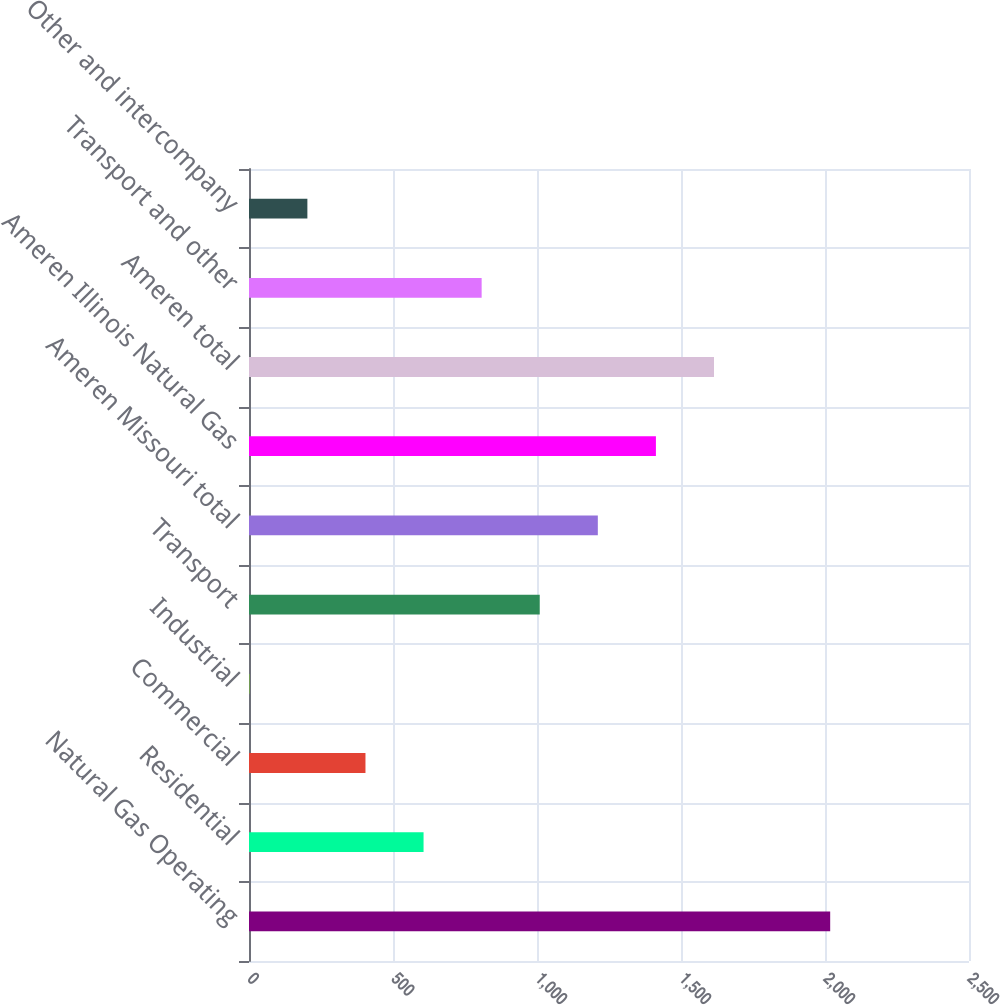Convert chart to OTSL. <chart><loc_0><loc_0><loc_500><loc_500><bar_chart><fcel>Natural Gas Operating<fcel>Residential<fcel>Commercial<fcel>Industrial<fcel>Transport<fcel>Ameren Missouri total<fcel>Ameren Illinois Natural Gas<fcel>Ameren total<fcel>Transport and other<fcel>Other and intercompany<nl><fcel>2018<fcel>606.1<fcel>404.4<fcel>1<fcel>1009.5<fcel>1211.2<fcel>1412.9<fcel>1614.6<fcel>807.8<fcel>202.7<nl></chart> 